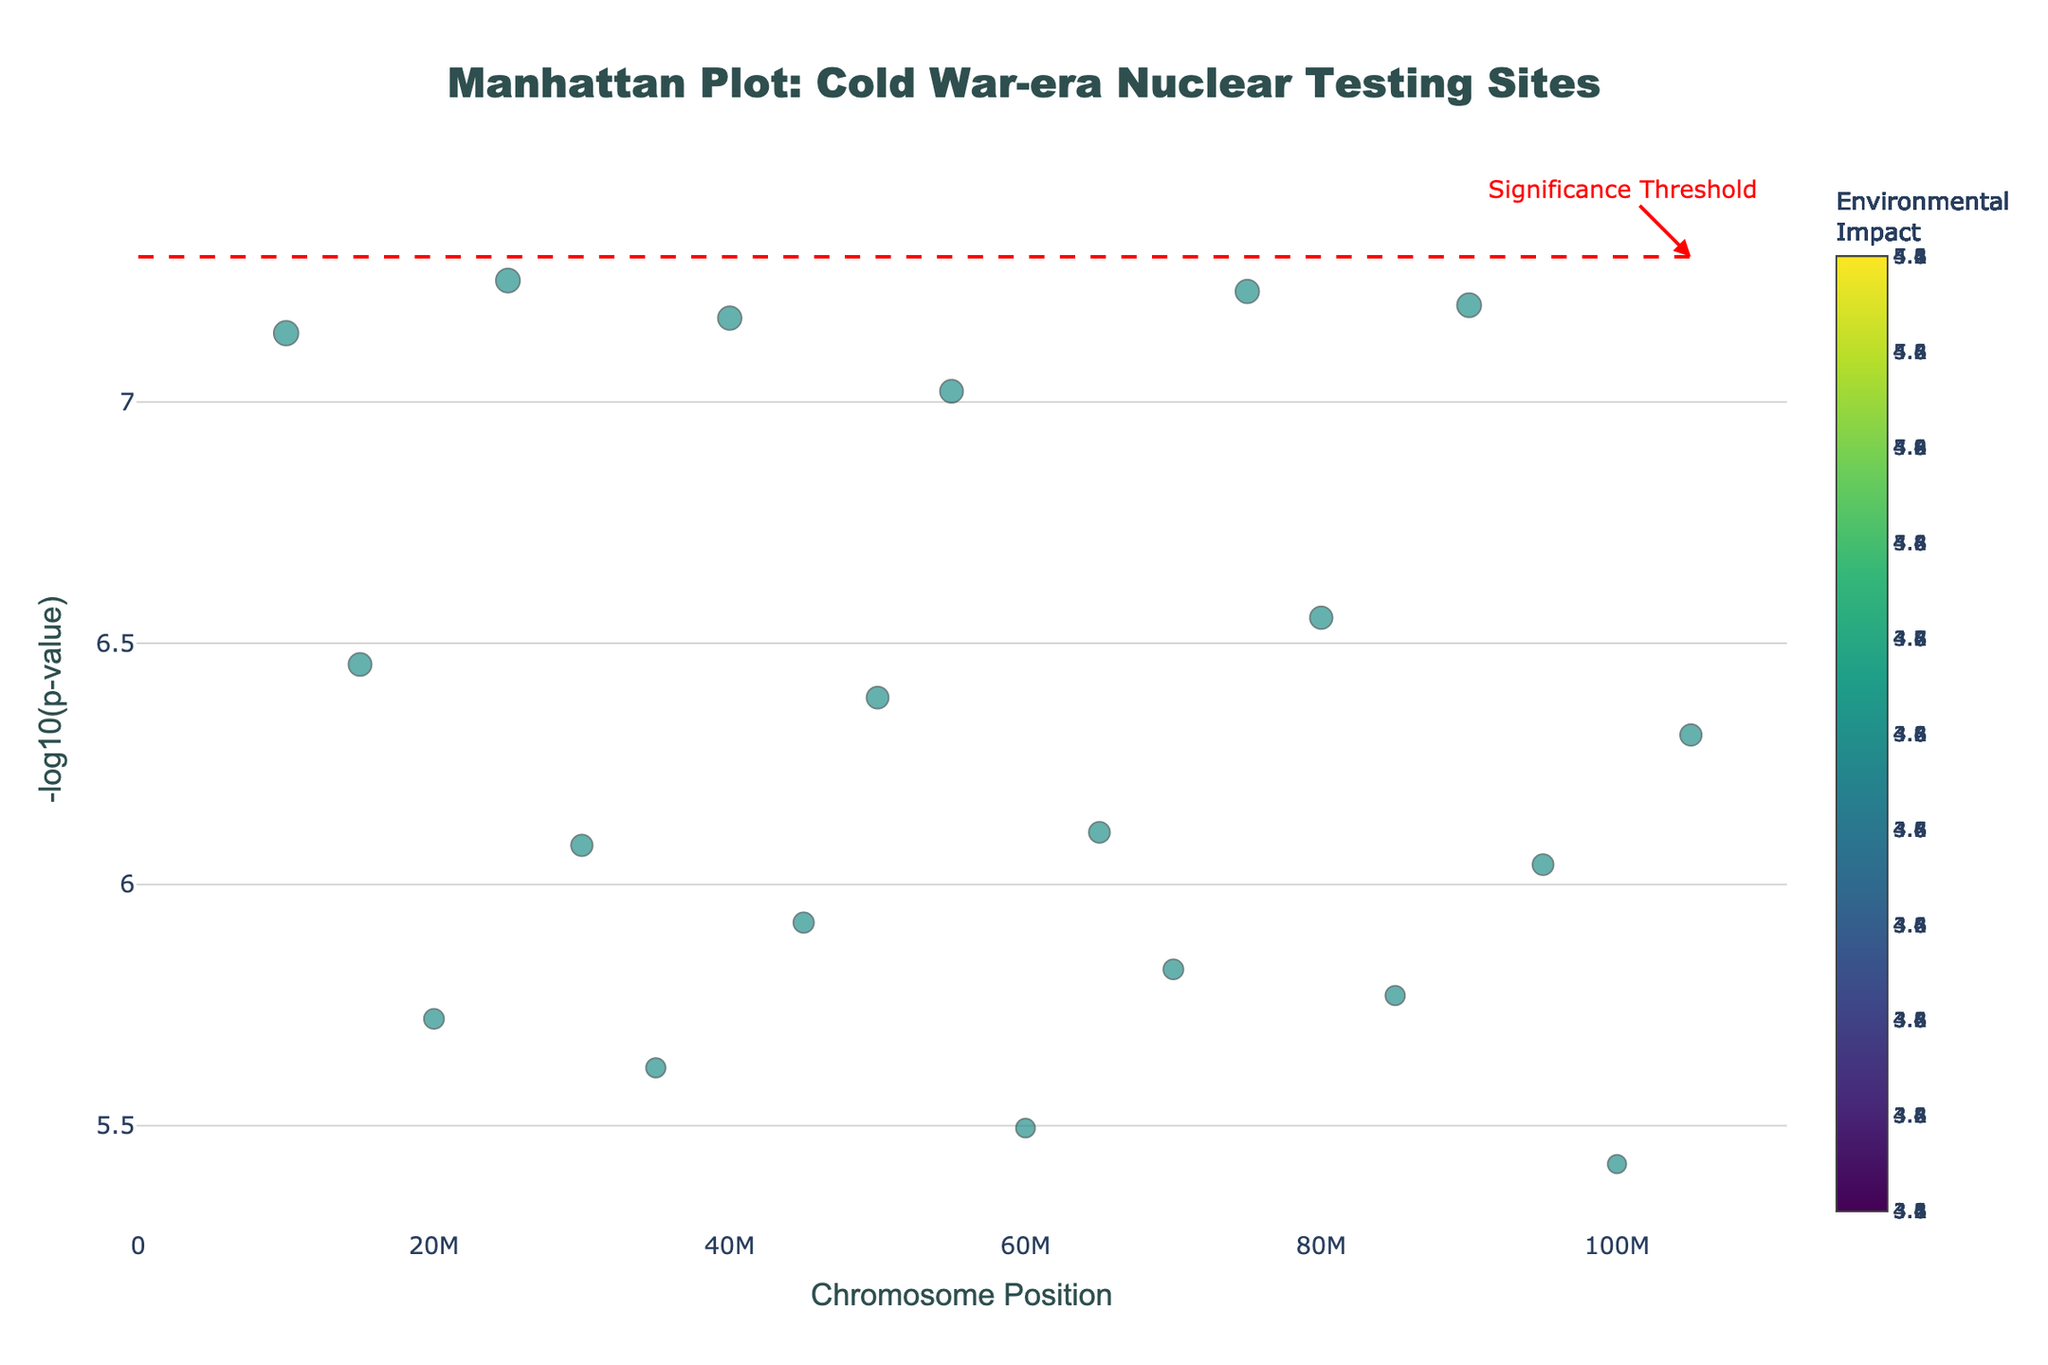What is the title of the Manhattan Plot? The title of the figure is displayed at the top center in a larger font size. It reads "Manhattan Plot: Cold War-era Nuclear Testing Sites"
Answer: Manhattan Plot: Cold War-era Nuclear Testing Sites How many nuclear testing sites are plotted in the Manhattan Plot? Count the number of distinct marker points displayed on the plot. Each marker represents a nuclear testing site.
Answer: 20 What does the y-axis represent? The y-axis title is visible on the plot's left side. It represents the -log10(p-value) for each nuclear testing site.
Answer: -log10(p-value) Which testing site has the smallest p-value? Identify the point with the highest -log10(p-value) on the y-axis. Check the hover text for details.
Answer: Nevada Test Site What is the environmental impact score of the Nevada Test Site? Hover over the point representing the Nevada Test Site to display detailed information, including the environmental impact score.
Answer: 4.8 Identify a chromosome with multiple testing sites and list the sites. By examining the plot, locate a chromosome with multiple marker points and use the hover text to identify the test sites. Chromosome 1 for instance does not have multiple sites, but Chromosome 2 to Chromosome 20 each represent a single unique test site.
Answer: Chromosome 1: N/A Which country has the most testing sites listed in the plot? Inspect the hover text for each testing site to identify the country. Count the occurrences of each country.
Answer: USA What is the average environmental impact score of the USA's testing sites? Extract the environmental impact scores for all USA sites. Compute the average: (4.8 + 4.1 + 3.7 + 4.1 + 3.8 + 3.6 + 4.2) / 7 = (27.3 / 7) = 3.9
Answer: 3.9 Compare the environmental impact scores of the Semipalatinsk Test Site and Lop Nur Test Site. Which one is higher? Check the hover text for both Semipalatinsk (chromosome 2) and Lop Nur (chromosome 3), and compare their environmental impact scores.
Answer: Semipalatinsk Test Site What is the significance threshold for p-values in this plot? A red horizontal dashed line is shown on the plot to indicate the significance threshold. The hover annotation specifies the threshold.
Answer: 5e-8 